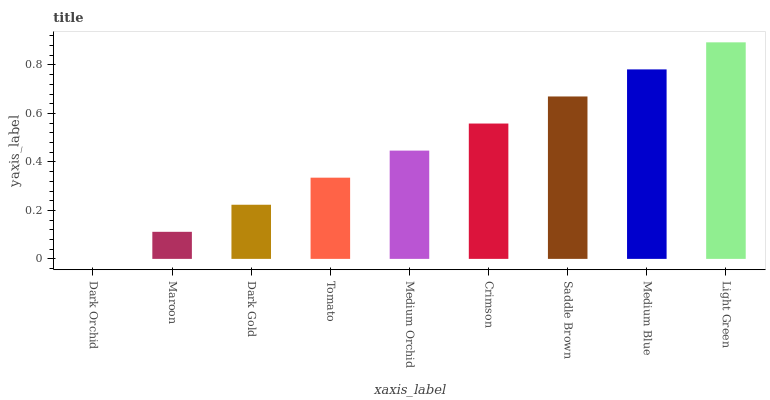Is Dark Orchid the minimum?
Answer yes or no. Yes. Is Light Green the maximum?
Answer yes or no. Yes. Is Maroon the minimum?
Answer yes or no. No. Is Maroon the maximum?
Answer yes or no. No. Is Maroon greater than Dark Orchid?
Answer yes or no. Yes. Is Dark Orchid less than Maroon?
Answer yes or no. Yes. Is Dark Orchid greater than Maroon?
Answer yes or no. No. Is Maroon less than Dark Orchid?
Answer yes or no. No. Is Medium Orchid the high median?
Answer yes or no. Yes. Is Medium Orchid the low median?
Answer yes or no. Yes. Is Dark Orchid the high median?
Answer yes or no. No. Is Tomato the low median?
Answer yes or no. No. 